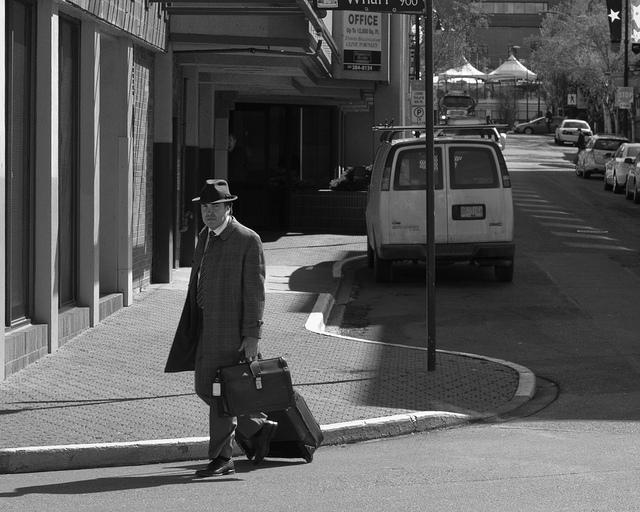How many people are standing on the side of the street?
Give a very brief answer. 1. How many bags are there?
Give a very brief answer. 2. How many trucks are there?
Give a very brief answer. 1. How many people are there?
Give a very brief answer. 1. 